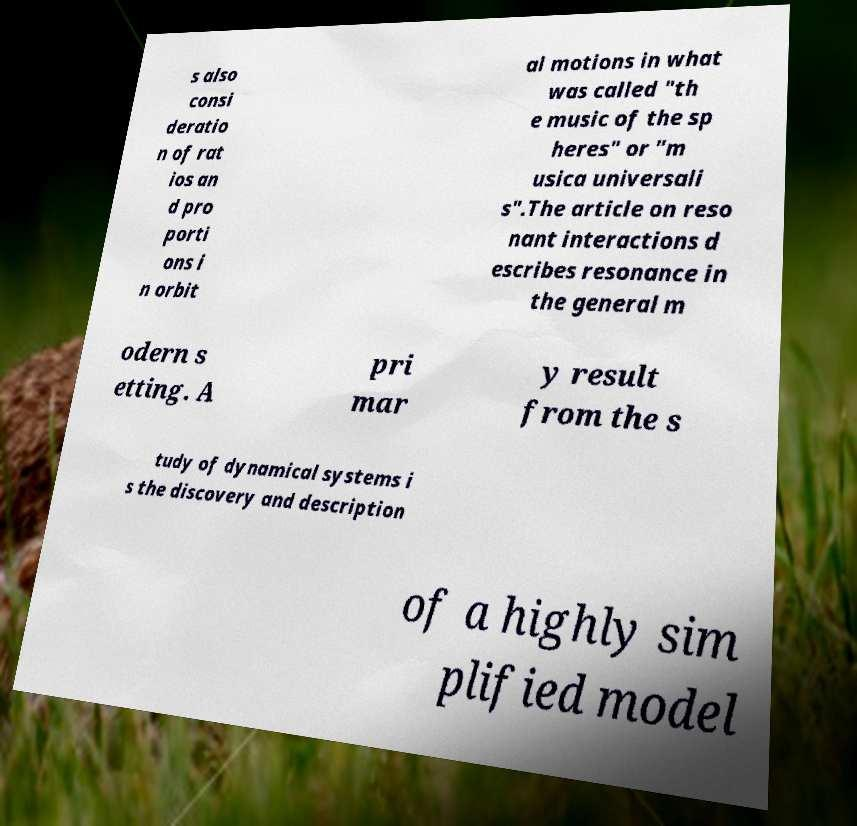Could you assist in decoding the text presented in this image and type it out clearly? s also consi deratio n of rat ios an d pro porti ons i n orbit al motions in what was called "th e music of the sp heres" or "m usica universali s".The article on reso nant interactions d escribes resonance in the general m odern s etting. A pri mar y result from the s tudy of dynamical systems i s the discovery and description of a highly sim plified model 